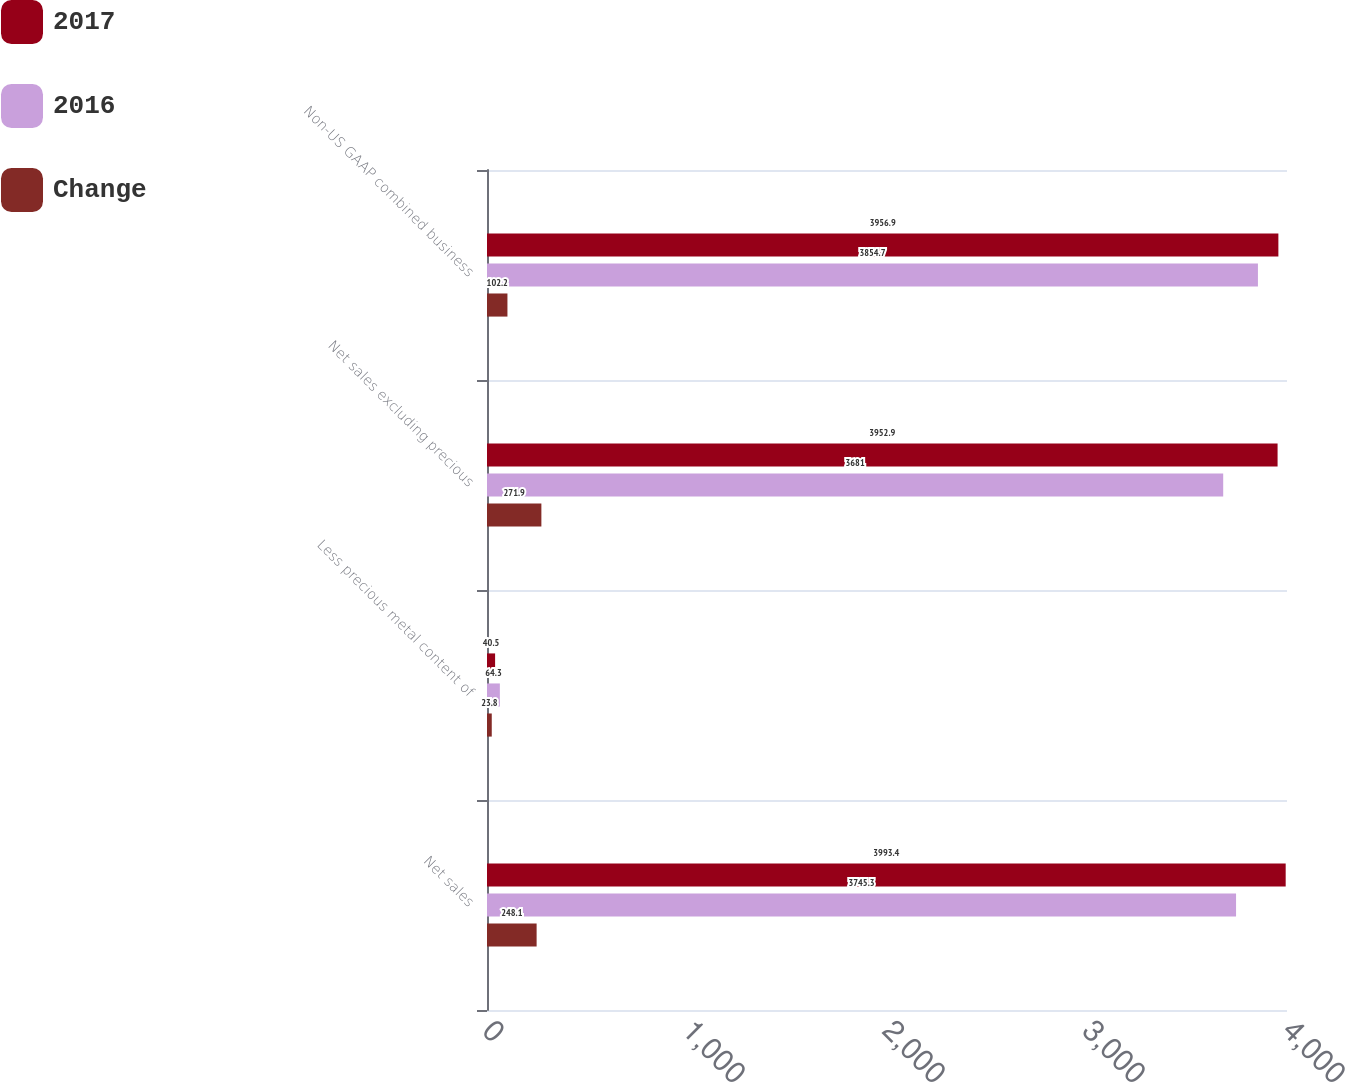Convert chart to OTSL. <chart><loc_0><loc_0><loc_500><loc_500><stacked_bar_chart><ecel><fcel>Net sales<fcel>Less precious metal content of<fcel>Net sales excluding precious<fcel>Non-US GAAP combined business<nl><fcel>2017<fcel>3993.4<fcel>40.5<fcel>3952.9<fcel>3956.9<nl><fcel>2016<fcel>3745.3<fcel>64.3<fcel>3681<fcel>3854.7<nl><fcel>Change<fcel>248.1<fcel>23.8<fcel>271.9<fcel>102.2<nl></chart> 